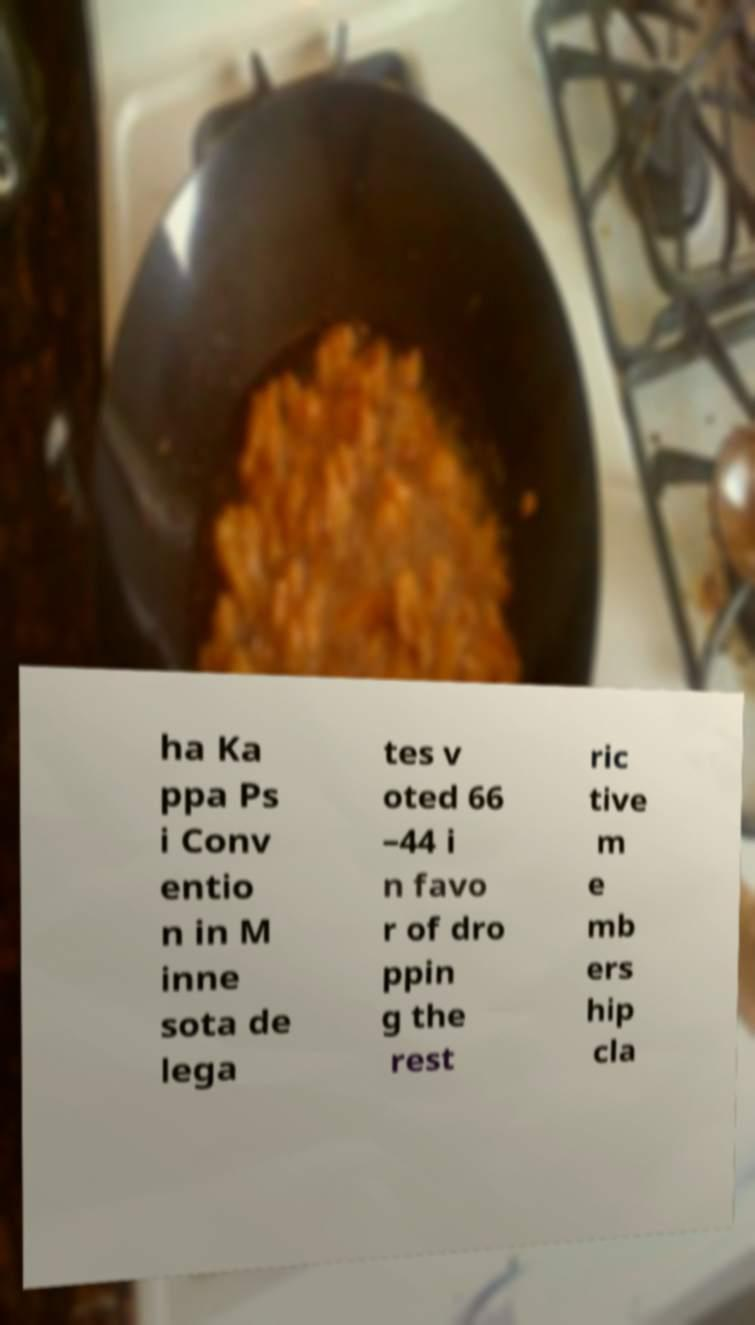Could you assist in decoding the text presented in this image and type it out clearly? ha Ka ppa Ps i Conv entio n in M inne sota de lega tes v oted 66 –44 i n favo r of dro ppin g the rest ric tive m e mb ers hip cla 